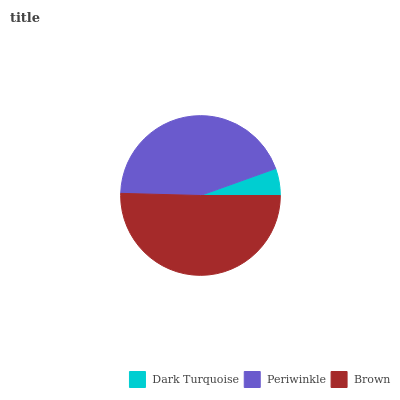Is Dark Turquoise the minimum?
Answer yes or no. Yes. Is Brown the maximum?
Answer yes or no. Yes. Is Periwinkle the minimum?
Answer yes or no. No. Is Periwinkle the maximum?
Answer yes or no. No. Is Periwinkle greater than Dark Turquoise?
Answer yes or no. Yes. Is Dark Turquoise less than Periwinkle?
Answer yes or no. Yes. Is Dark Turquoise greater than Periwinkle?
Answer yes or no. No. Is Periwinkle less than Dark Turquoise?
Answer yes or no. No. Is Periwinkle the high median?
Answer yes or no. Yes. Is Periwinkle the low median?
Answer yes or no. Yes. Is Dark Turquoise the high median?
Answer yes or no. No. Is Brown the low median?
Answer yes or no. No. 